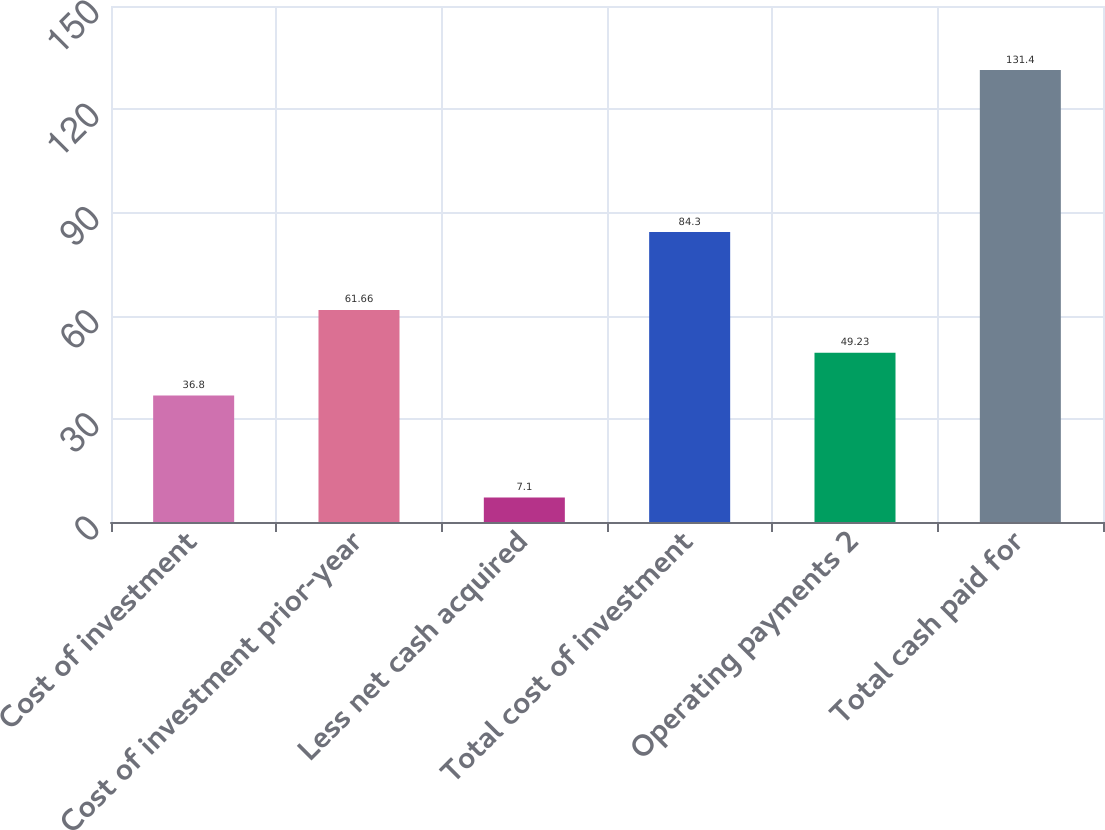<chart> <loc_0><loc_0><loc_500><loc_500><bar_chart><fcel>Cost of investment<fcel>Cost of investment prior-year<fcel>Less net cash acquired<fcel>Total cost of investment<fcel>Operating payments 2<fcel>Total cash paid for<nl><fcel>36.8<fcel>61.66<fcel>7.1<fcel>84.3<fcel>49.23<fcel>131.4<nl></chart> 